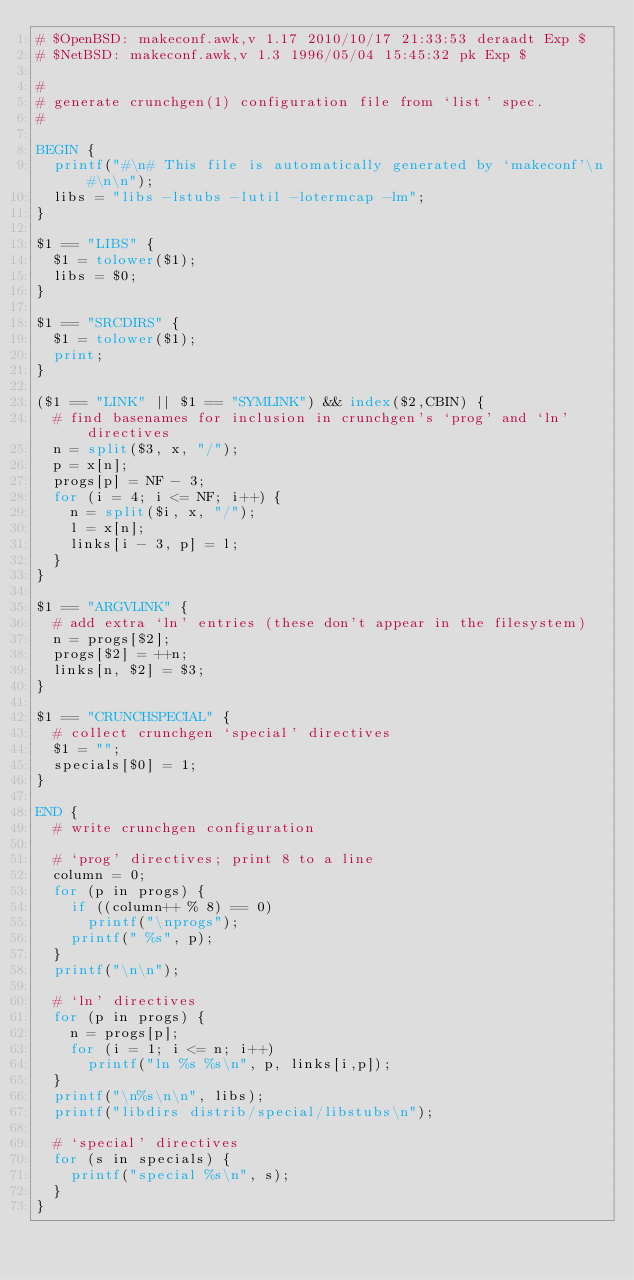<code> <loc_0><loc_0><loc_500><loc_500><_Awk_>#	$OpenBSD: makeconf.awk,v 1.17 2010/10/17 21:33:53 deraadt Exp $
#	$NetBSD: makeconf.awk,v 1.3 1996/05/04 15:45:32 pk Exp $

#
# generate crunchgen(1) configuration file from `list' spec.
#

BEGIN {
	printf("#\n# This file is automatically generated by `makeconf'\n#\n\n");
	libs = "libs -lstubs -lutil -lotermcap -lm";
}

$1 == "LIBS" {
	$1 = tolower($1);
	libs = $0;
}

$1 == "SRCDIRS" {
	$1 = tolower($1);
	print;
}

($1 == "LINK" || $1 == "SYMLINK") && index($2,CBIN) {
	# find basenames for inclusion in crunchgen's `prog' and `ln' directives
	n = split($3, x, "/");
	p = x[n];
	progs[p] = NF - 3;
	for (i = 4; i <= NF; i++) {
		n = split($i, x, "/");
		l = x[n];
		links[i - 3, p] = l;
	}
}

$1 == "ARGVLINK" {
	# add extra `ln' entries (these don't appear in the filesystem)
	n = progs[$2];
	progs[$2] = ++n;
	links[n, $2] = $3;
}

$1 == "CRUNCHSPECIAL" {
	# collect crunchgen `special' directives
	$1 = "";
	specials[$0] = 1;
}

END {
	# write crunchgen configuration

	# `prog' directives; print 8 to a line
	column = 0;
	for (p in progs) {
		if ((column++ % 8) == 0)
			printf("\nprogs");
		printf(" %s", p);
	}
	printf("\n\n");

	# `ln' directives
	for (p in progs) {
		n = progs[p];
		for (i = 1; i <= n; i++)
			printf("ln %s %s\n", p, links[i,p]);
	}
	printf("\n%s\n\n", libs);
	printf("libdirs distrib/special/libstubs\n");

	# `special' directives
	for (s in specials) {
		printf("special %s\n", s);
	}
}
</code> 